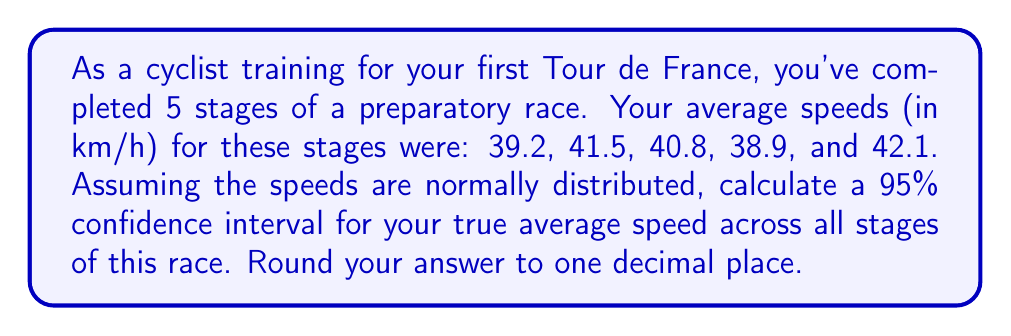Solve this math problem. Let's approach this step-by-step:

1) First, we need to calculate the sample mean ($\bar{x}$) and sample standard deviation ($s$):

   $\bar{x} = \frac{39.2 + 41.5 + 40.8 + 38.9 + 42.1}{5} = 40.5$ km/h

   $s = \sqrt{\frac{\sum(x_i - \bar{x})^2}{n-1}}$ 
   $= \sqrt{\frac{(-1.3)^2 + 1^2 + 0.3^2 + (-1.6)^2 + 1.6^2}{4}} \approx 1.4177$ km/h

2) The formula for a confidence interval is:

   $\bar{x} \pm t_{\alpha/2, n-1} \cdot \frac{s}{\sqrt{n}}$

   Where $t_{\alpha/2, n-1}$ is the t-value for a 95% confidence interval with 4 degrees of freedom.

3) For a 95% confidence interval with 4 degrees of freedom, $t_{0.025, 4} = 2.776$ (from t-distribution table)

4) Now we can calculate the margin of error:

   $2.776 \cdot \frac{1.4177}{\sqrt{5}} \approx 1.7594$

5) Therefore, the 95% confidence interval is:

   $40.5 \pm 1.7594$

   $[38.7406, 42.2594]$

6) Rounding to one decimal place:

   $[38.7, 42.3]$ km/h
Answer: [38.7, 42.3] km/h 